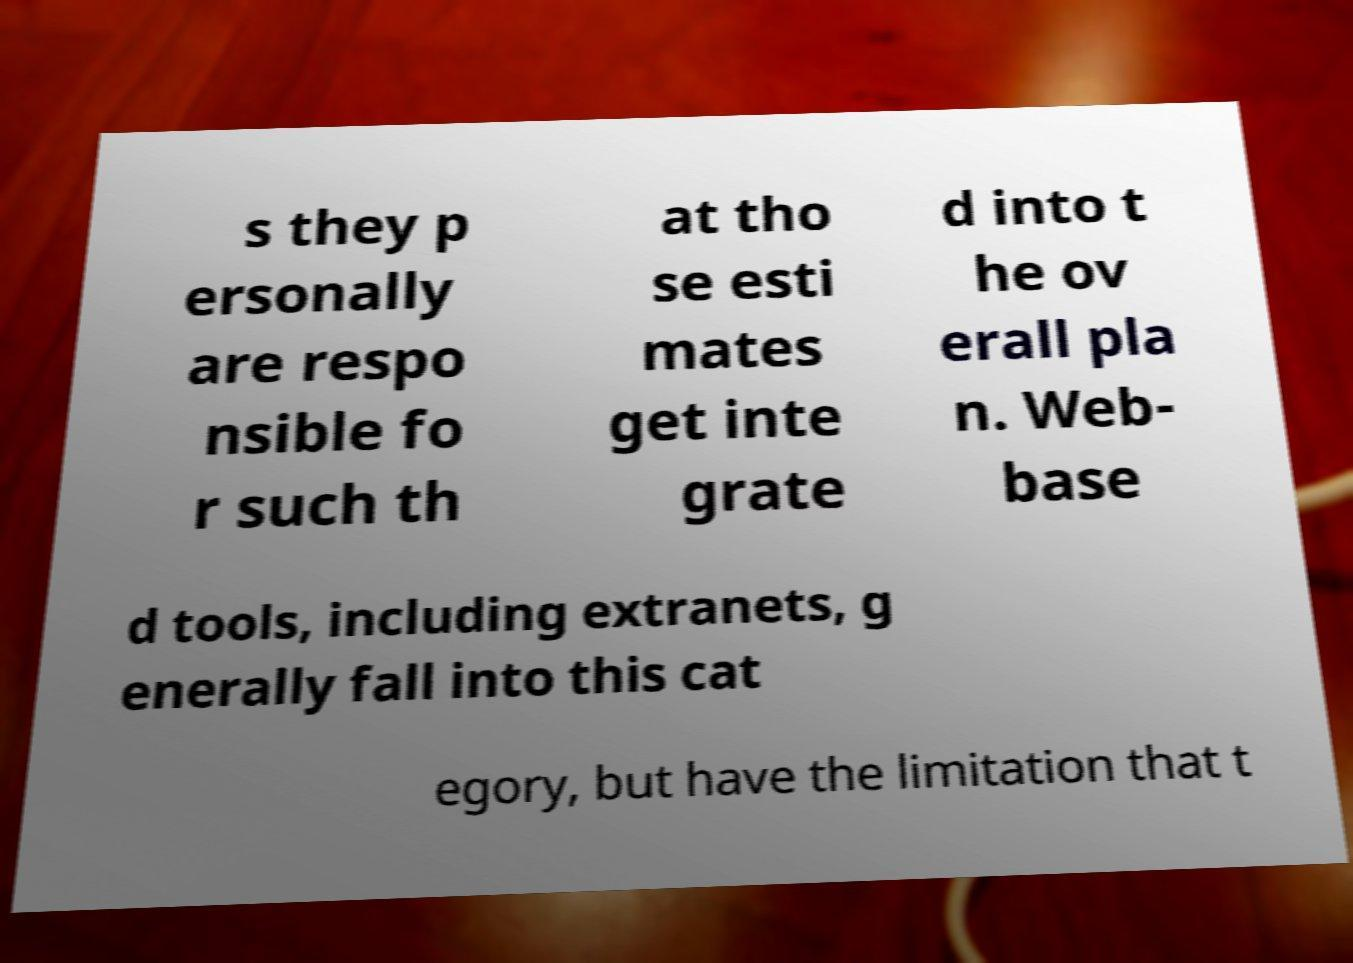I need the written content from this picture converted into text. Can you do that? s they p ersonally are respo nsible fo r such th at tho se esti mates get inte grate d into t he ov erall pla n. Web- base d tools, including extranets, g enerally fall into this cat egory, but have the limitation that t 